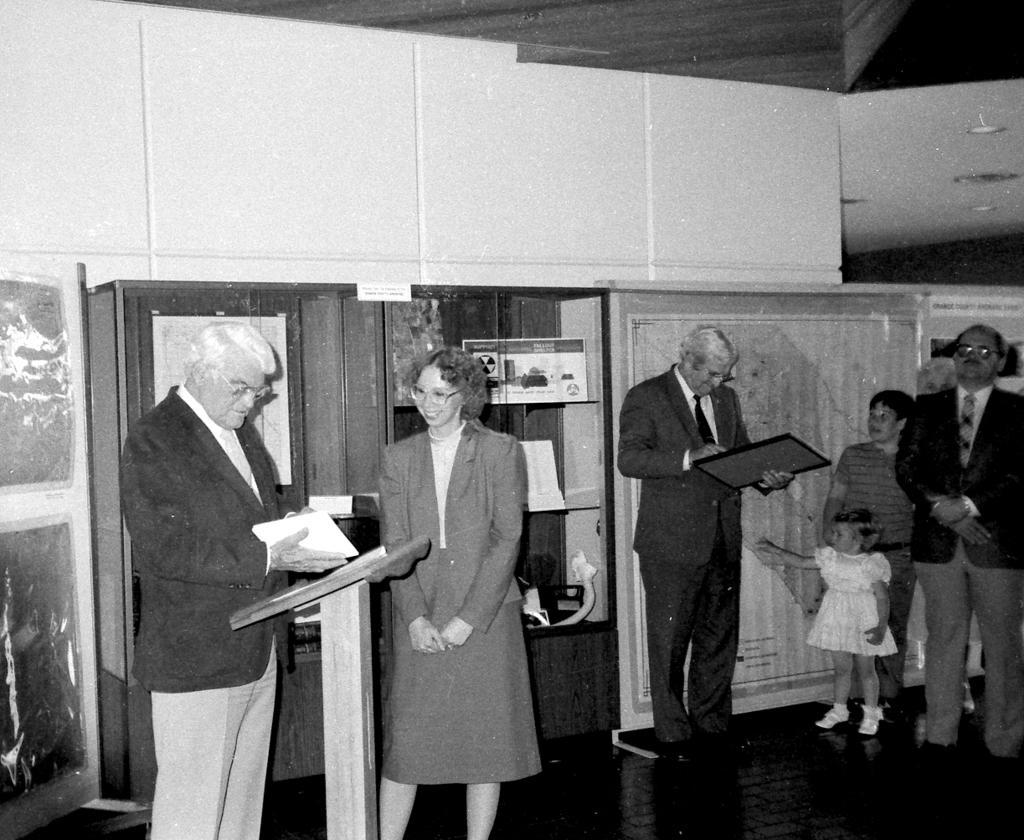Could you give a brief overview of what you see in this image? In this image I can see few people standing and wearing the dresses. I can see two people are holding something. In the background I can see the boards and some objects in the rack. And this is a black and white image. 